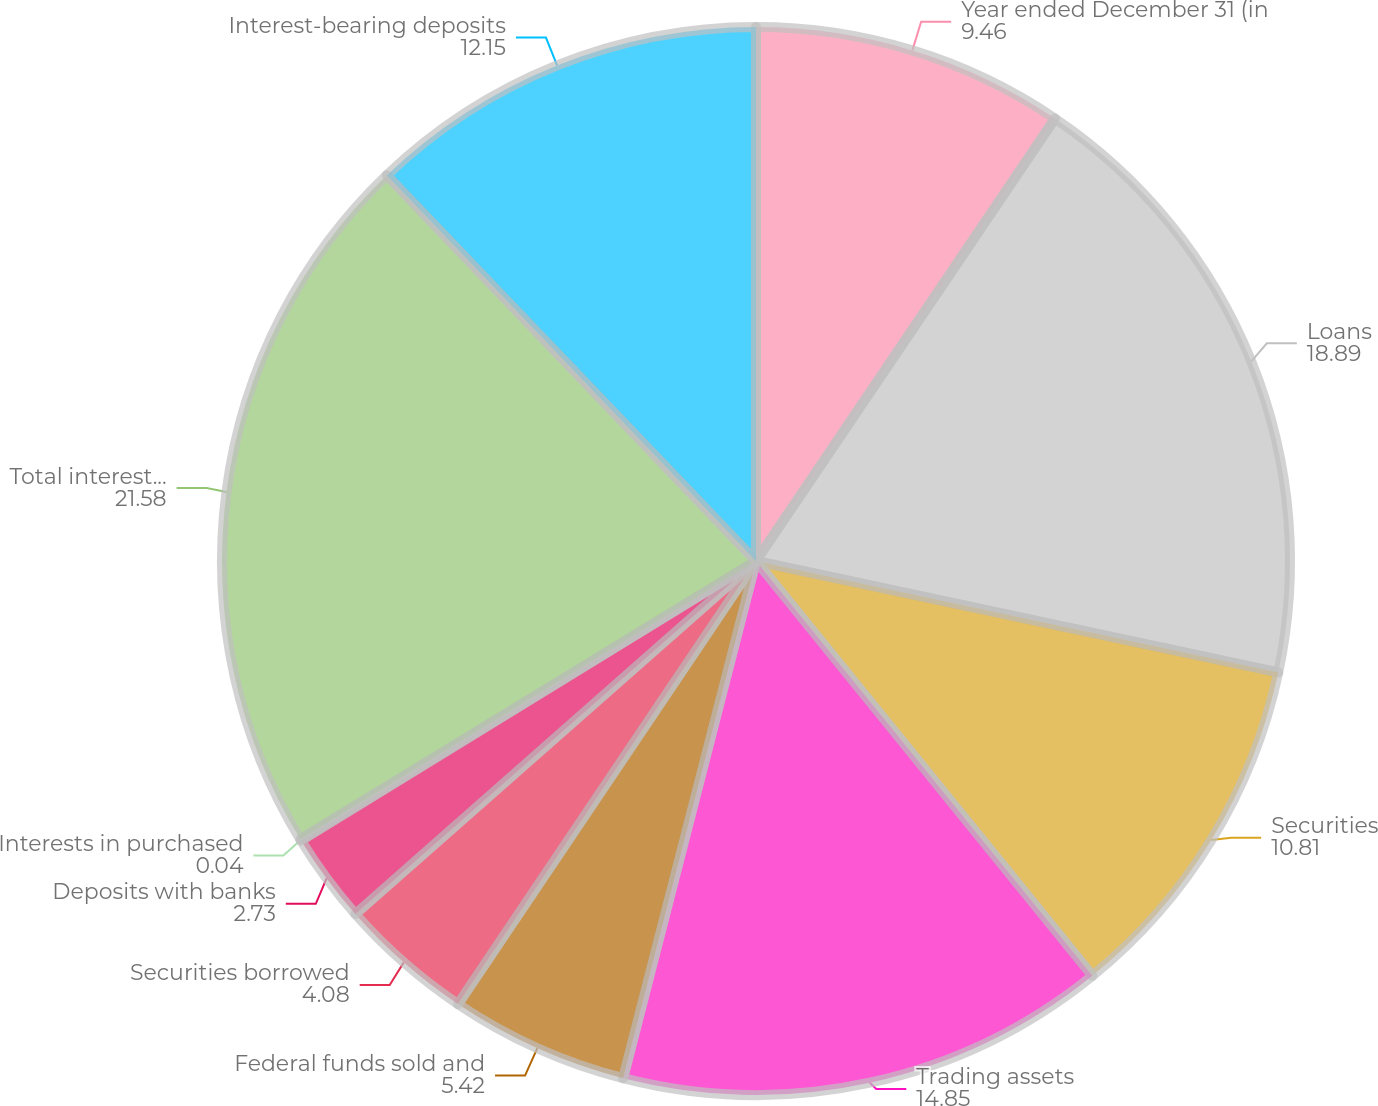<chart> <loc_0><loc_0><loc_500><loc_500><pie_chart><fcel>Year ended December 31 (in<fcel>Loans<fcel>Securities<fcel>Trading assets<fcel>Federal funds sold and<fcel>Securities borrowed<fcel>Deposits with banks<fcel>Interests in purchased<fcel>Total interest income<fcel>Interest-bearing deposits<nl><fcel>9.46%<fcel>18.89%<fcel>10.81%<fcel>14.85%<fcel>5.42%<fcel>4.08%<fcel>2.73%<fcel>0.04%<fcel>21.58%<fcel>12.15%<nl></chart> 